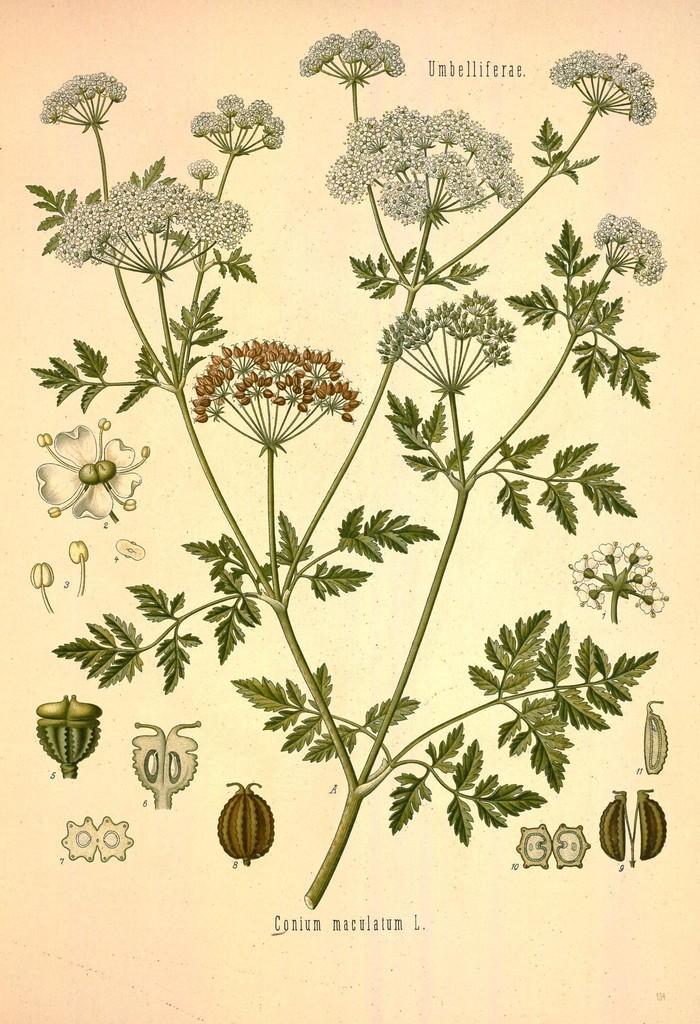Please provide a concise description of this image. This is a painting and here we can see a plant with flowers and there are buds and we can see some text. 